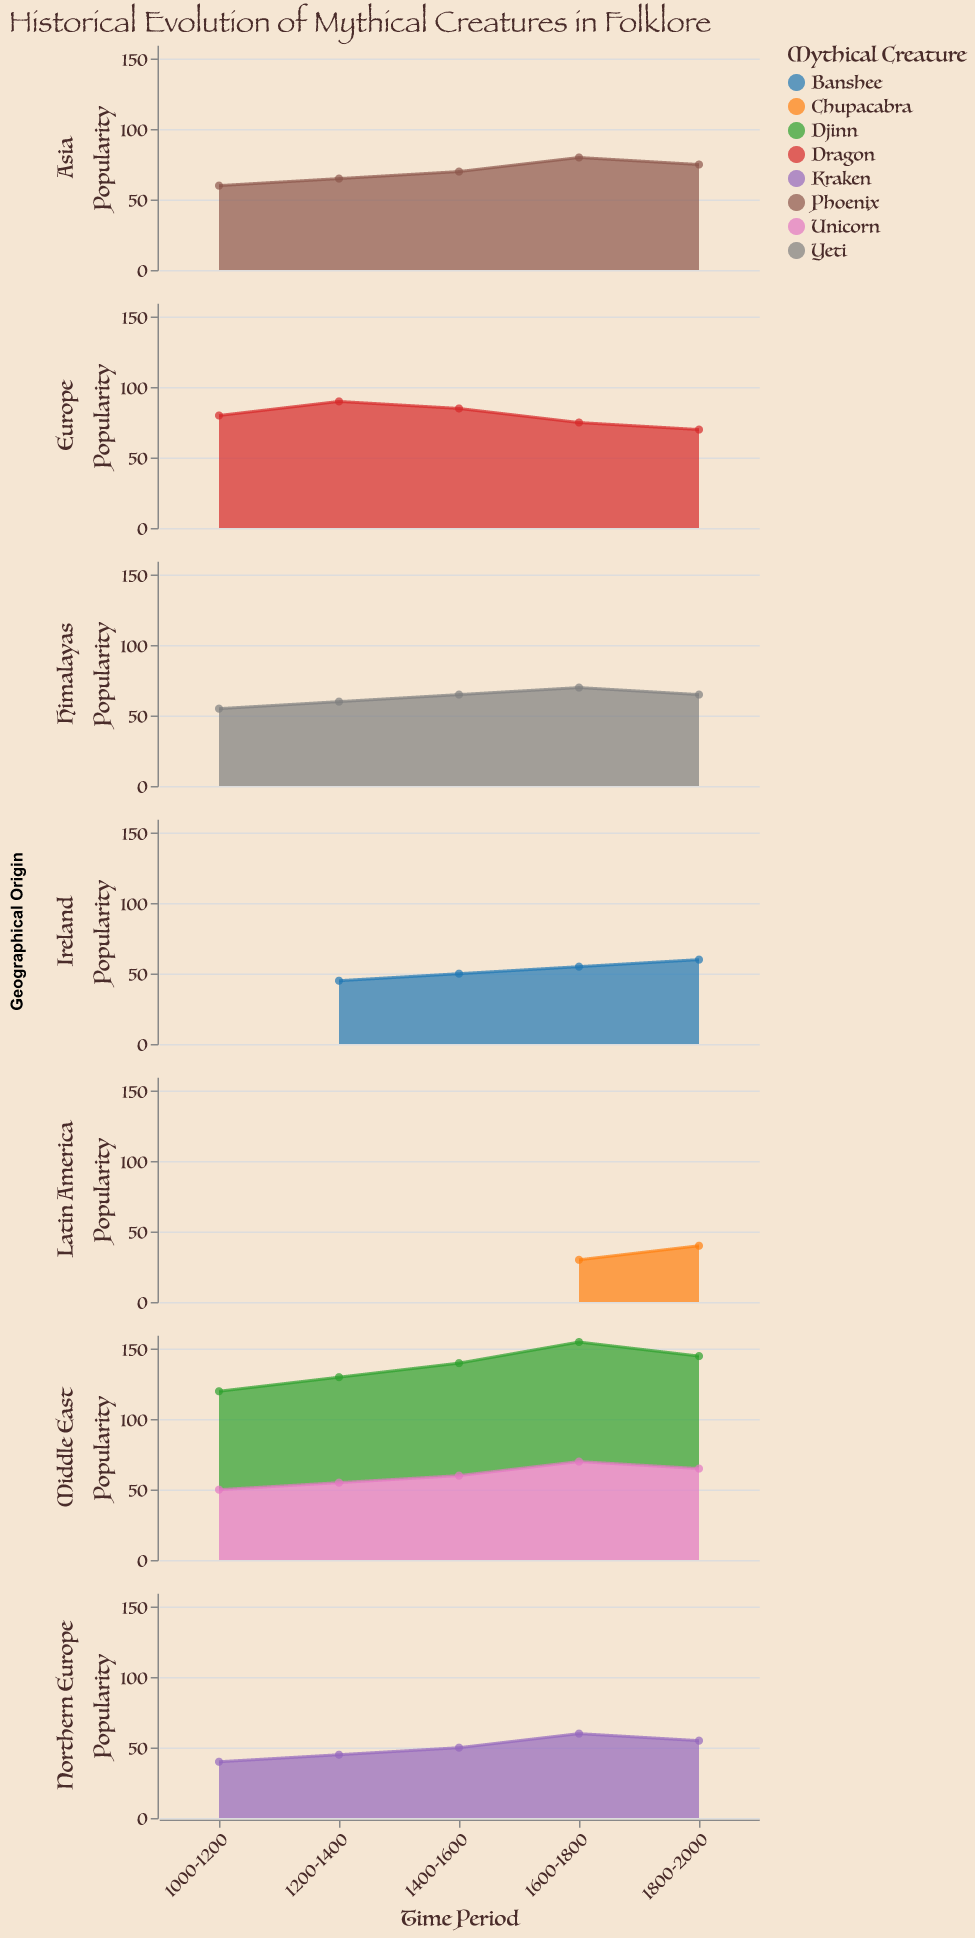What is the geographical origin with the highest popularity of dragons in the 1200-1400 period? In the plot for Europe's geographical region, during the 1200-1400 period, the popularity for dragons is shown to be 90. By examining other geographical regions, no other location listed dragons, confirming Europe is the highest.
Answer: Europe Which mythical creature from the Middle East showed a consistent increase in popularity from 1000 to 1800? Looking at the Middle East subplot, Djinn shows an increase in popularity from 70 in 1000-1200, to 75 in 1200-1400, to 80 in 1400-1600, and 85 in 1600-1800.
Answer: Djinn Between 1600 and 1800, which mythical creature was the least popular in Northern Europe? Reviewing the Northern Europe subplot for the specified time period, Kraken has a popularity value of 60. Since Kraken is the only mythical creature in this subplot, it is the least popular by default.
Answer: Kraken How did the popularity of the Chupacabra change between 1600 and 2000 in Latin America? Checking the Latin America subplot, Chupacabra's popularity increased from 30 in 1600-1800 to 40 in 1800-2000, showing an increase by 10 units over the time period.
Answer: Increased by 10 Which mythical creature in the Himalayas reached its peak popularity in the 1600-1800 period? Examining the Himalayas subplot, the Yeti’s popularity is highest during the 1600-1800 period, peaking at 70.
Answer: Yeti What is the average popularity of the Phoenix in Asia across all time periods? Summing the popularity values for Phoenix in Asia (60 + 65 + 70 + 80 + 75) equals 350. Dividing by the 5 time periods results in an average of 70.
Answer: 70 What creature has the highest popularity in the '1400-1600' period for the Middle East? In the Middle East subplot for 1400-1600, Djinn records a popularity of 80, which is higher than Unicorn’s 60.
Answer: Djinn Compare the popularity trend of Banshee in Ireland with that of the Phoenix in Asia over time. Banshee rises from 45 to 50 to 55 then 60, while Phoenix rises from 60 to 65 to 70 peaks at 80, but then decreases to 75. Banshee has a consistent rise, whereas Phoenix has an initial rise then a slight decline.
Answer: Banshee consistently rises; Phoenix peaks then slightly declines In which period did the Unicorn in the Middle East see its maximum popularity? Referring to the Middle East subplot, Unicorn's popularity peaks at 70 during the 1600-1800 period.
Answer: 1600-1800 